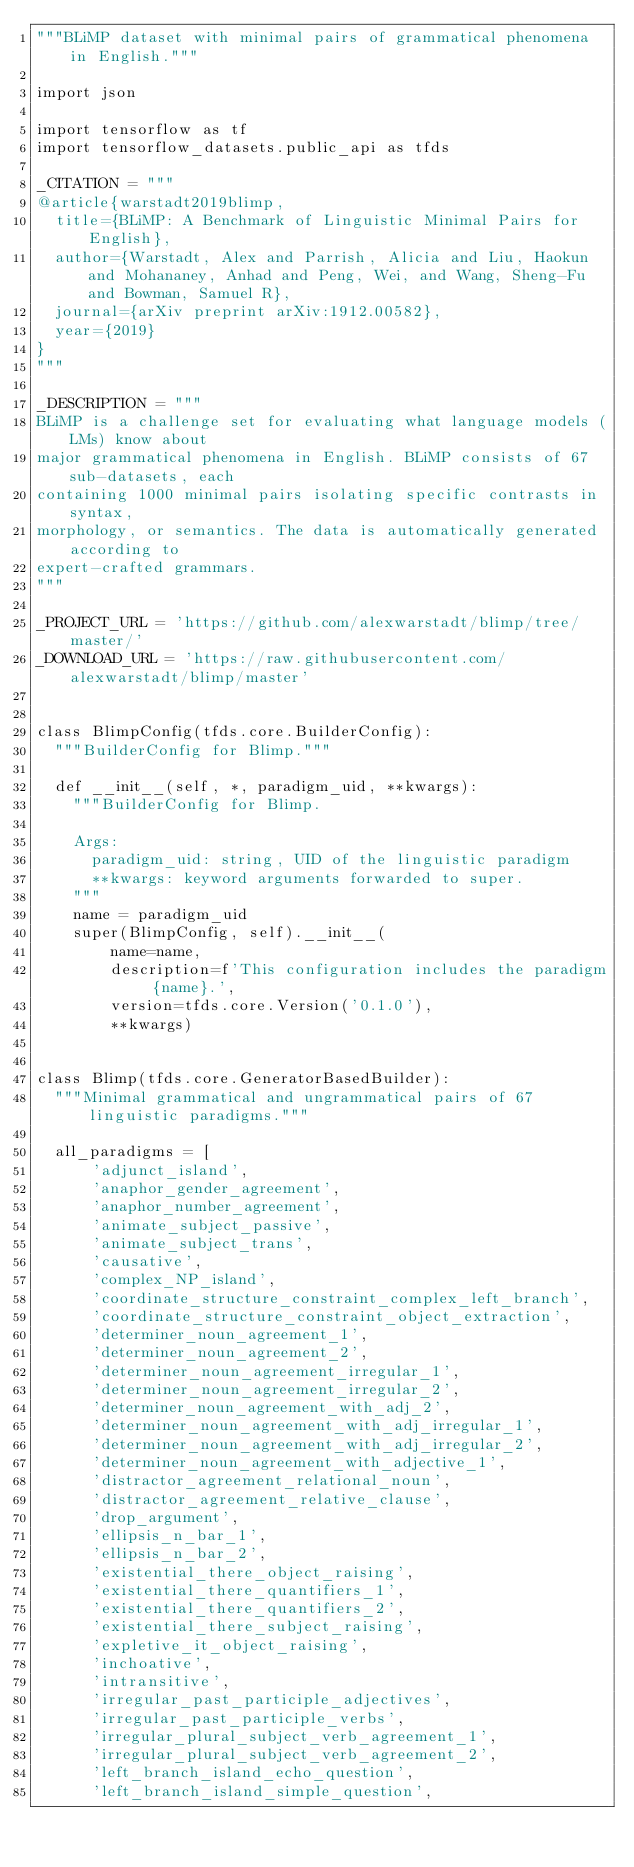Convert code to text. <code><loc_0><loc_0><loc_500><loc_500><_Python_>"""BLiMP dataset with minimal pairs of grammatical phenomena in English."""

import json

import tensorflow as tf
import tensorflow_datasets.public_api as tfds

_CITATION = """
@article{warstadt2019blimp,
  title={BLiMP: A Benchmark of Linguistic Minimal Pairs for English},
  author={Warstadt, Alex and Parrish, Alicia and Liu, Haokun and Mohananey, Anhad and Peng, Wei, and Wang, Sheng-Fu and Bowman, Samuel R},
  journal={arXiv preprint arXiv:1912.00582},
  year={2019}
}
"""

_DESCRIPTION = """
BLiMP is a challenge set for evaluating what language models (LMs) know about
major grammatical phenomena in English. BLiMP consists of 67 sub-datasets, each
containing 1000 minimal pairs isolating specific contrasts in syntax,
morphology, or semantics. The data is automatically generated according to
expert-crafted grammars.
"""

_PROJECT_URL = 'https://github.com/alexwarstadt/blimp/tree/master/'
_DOWNLOAD_URL = 'https://raw.githubusercontent.com/alexwarstadt/blimp/master'


class BlimpConfig(tfds.core.BuilderConfig):
  """BuilderConfig for Blimp."""

  def __init__(self, *, paradigm_uid, **kwargs):
    """BuilderConfig for Blimp.

    Args:
      paradigm_uid: string, UID of the linguistic paradigm
      **kwargs: keyword arguments forwarded to super.
    """
    name = paradigm_uid
    super(BlimpConfig, self).__init__(
        name=name,
        description=f'This configuration includes the paradigm {name}.',
        version=tfds.core.Version('0.1.0'),
        **kwargs)


class Blimp(tfds.core.GeneratorBasedBuilder):
  """Minimal grammatical and ungrammatical pairs of 67 linguistic paradigms."""

  all_paradigms = [
      'adjunct_island',
      'anaphor_gender_agreement',
      'anaphor_number_agreement',
      'animate_subject_passive',
      'animate_subject_trans',
      'causative',
      'complex_NP_island',
      'coordinate_structure_constraint_complex_left_branch',
      'coordinate_structure_constraint_object_extraction',
      'determiner_noun_agreement_1',
      'determiner_noun_agreement_2',
      'determiner_noun_agreement_irregular_1',
      'determiner_noun_agreement_irregular_2',
      'determiner_noun_agreement_with_adj_2',
      'determiner_noun_agreement_with_adj_irregular_1',
      'determiner_noun_agreement_with_adj_irregular_2',
      'determiner_noun_agreement_with_adjective_1',
      'distractor_agreement_relational_noun',
      'distractor_agreement_relative_clause',
      'drop_argument',
      'ellipsis_n_bar_1',
      'ellipsis_n_bar_2',
      'existential_there_object_raising',
      'existential_there_quantifiers_1',
      'existential_there_quantifiers_2',
      'existential_there_subject_raising',
      'expletive_it_object_raising',
      'inchoative',
      'intransitive',
      'irregular_past_participle_adjectives',
      'irregular_past_participle_verbs',
      'irregular_plural_subject_verb_agreement_1',
      'irregular_plural_subject_verb_agreement_2',
      'left_branch_island_echo_question',
      'left_branch_island_simple_question',</code> 